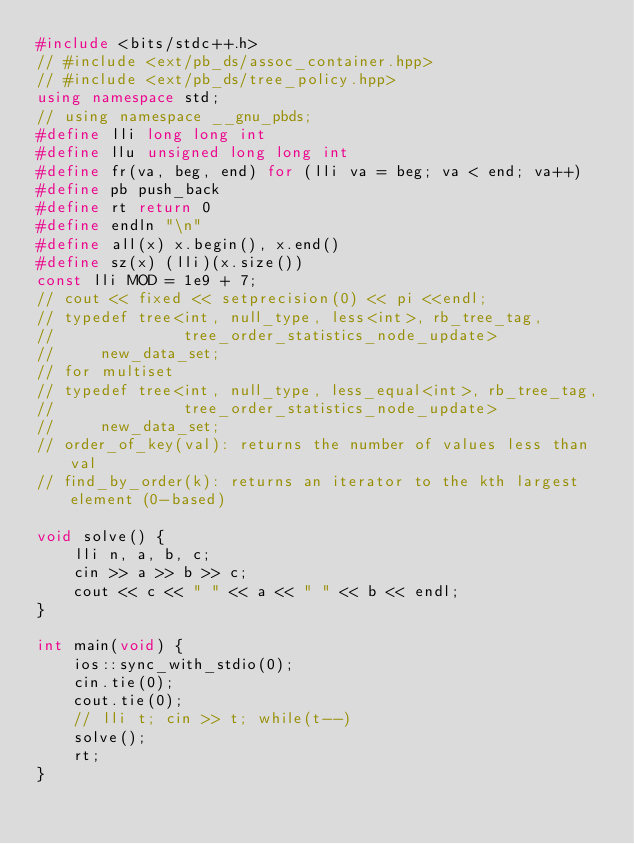Convert code to text. <code><loc_0><loc_0><loc_500><loc_500><_C++_>#include <bits/stdc++.h>
// #include <ext/pb_ds/assoc_container.hpp>
// #include <ext/pb_ds/tree_policy.hpp>
using namespace std;
// using namespace __gnu_pbds;
#define lli long long int
#define llu unsigned long long int
#define fr(va, beg, end) for (lli va = beg; va < end; va++)
#define pb push_back
#define rt return 0
#define endln "\n"
#define all(x) x.begin(), x.end()
#define sz(x) (lli)(x.size())
const lli MOD = 1e9 + 7;
// cout << fixed << setprecision(0) << pi <<endl;
// typedef tree<int, null_type, less<int>, rb_tree_tag,
//              tree_order_statistics_node_update>
//     new_data_set;
// for multiset
// typedef tree<int, null_type, less_equal<int>, rb_tree_tag,
//              tree_order_statistics_node_update>
//     new_data_set;
// order_of_key(val): returns the number of values less than val
// find_by_order(k): returns an iterator to the kth largest element (0-based)

void solve() {
    lli n, a, b, c;
    cin >> a >> b >> c;
    cout << c << " " << a << " " << b << endl;
}

int main(void) {
    ios::sync_with_stdio(0);
    cin.tie(0);
    cout.tie(0);
    // lli t; cin >> t; while(t--)
    solve();
    rt;
}</code> 